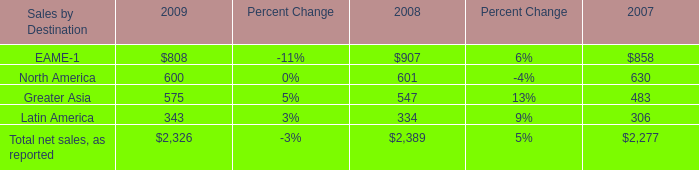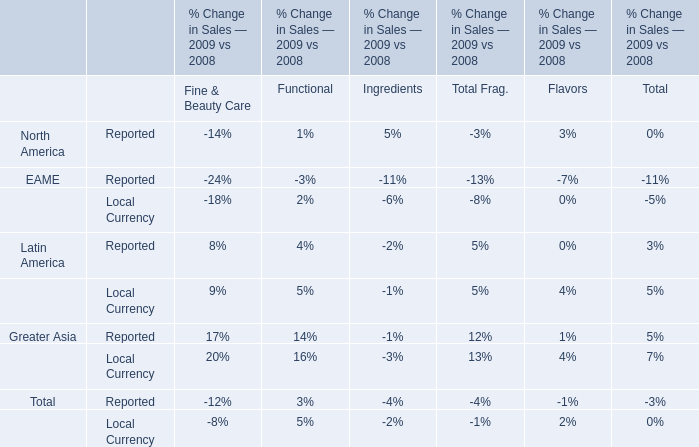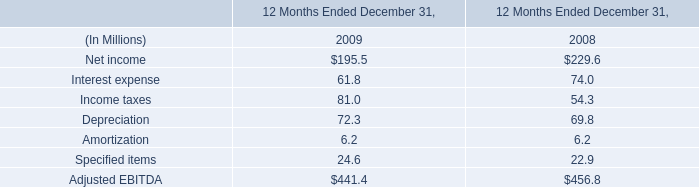In the year with highest net sales, as reported for Sales by Destination Greater Asia, what's the growing rate of net sales, as reported for Sales by Destination North America? 
Computations: ((600 - 601) / 601)
Answer: -0.00166. 